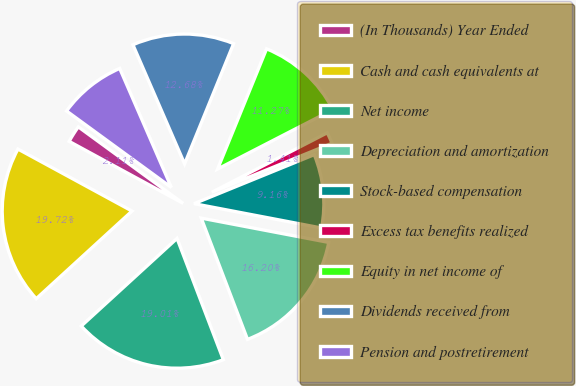Convert chart to OTSL. <chart><loc_0><loc_0><loc_500><loc_500><pie_chart><fcel>(In Thousands) Year Ended<fcel>Cash and cash equivalents at<fcel>Net income<fcel>Depreciation and amortization<fcel>Stock-based compensation<fcel>Excess tax benefits realized<fcel>Equity in net income of<fcel>Dividends received from<fcel>Pension and postretirement<nl><fcel>2.11%<fcel>19.72%<fcel>19.01%<fcel>16.2%<fcel>9.16%<fcel>1.41%<fcel>11.27%<fcel>12.68%<fcel>8.45%<nl></chart> 